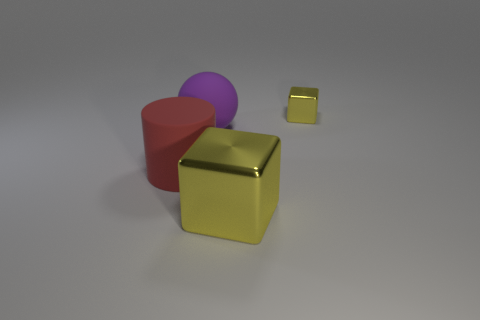The thing that is behind the big shiny cube and right of the purple ball is what color?
Keep it short and to the point. Yellow. Are there an equal number of yellow cubes that are behind the large purple object and big yellow metallic cubes in front of the big cylinder?
Your answer should be very brief. Yes. What is the color of the object that is the same material as the red cylinder?
Your response must be concise. Purple. There is a large cube; does it have the same color as the big rubber thing to the left of the big rubber ball?
Offer a very short reply. No. Is there a ball that is behind the yellow shiny block that is in front of the yellow metallic cube that is right of the large block?
Provide a succinct answer. Yes. What shape is the other yellow object that is the same material as the tiny thing?
Keep it short and to the point. Cube. Is there any other thing that has the same shape as the big purple matte thing?
Give a very brief answer. No. What is the shape of the small yellow metallic thing?
Provide a succinct answer. Cube. There is a yellow object behind the purple object; is it the same shape as the large metal object?
Keep it short and to the point. Yes. Is the number of large balls that are in front of the small yellow block greater than the number of matte spheres on the left side of the big purple thing?
Give a very brief answer. Yes. 